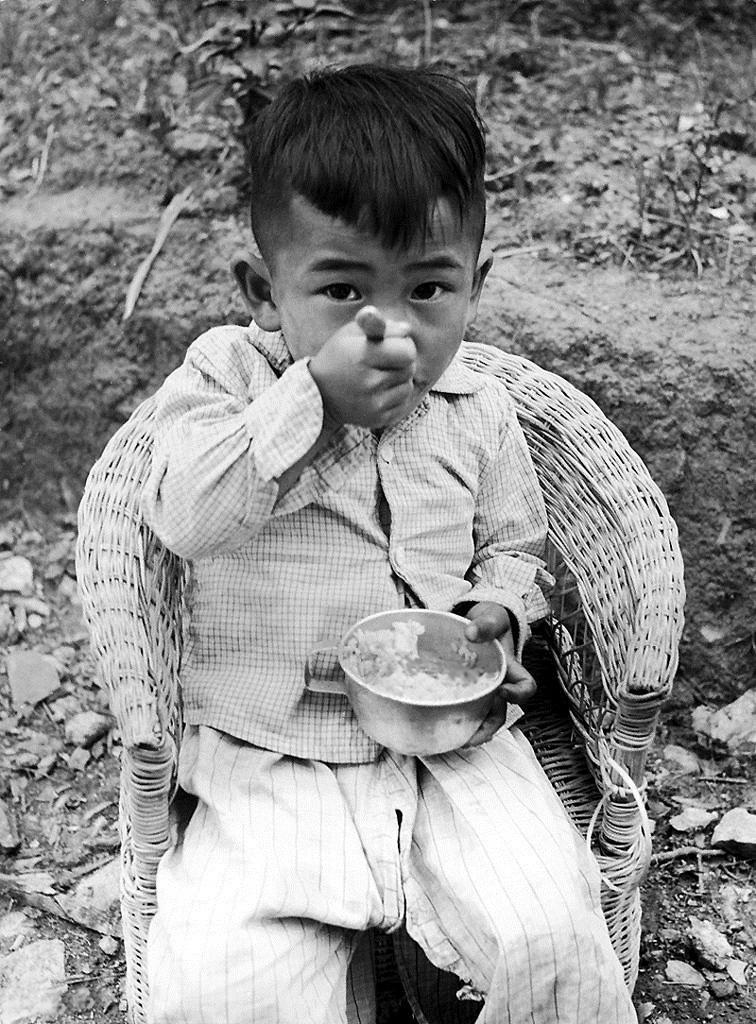Please provide a concise description of this image. This is a black and white image where a boy is sitting on a chair and is eating and behind him there are rocks on the ground. 